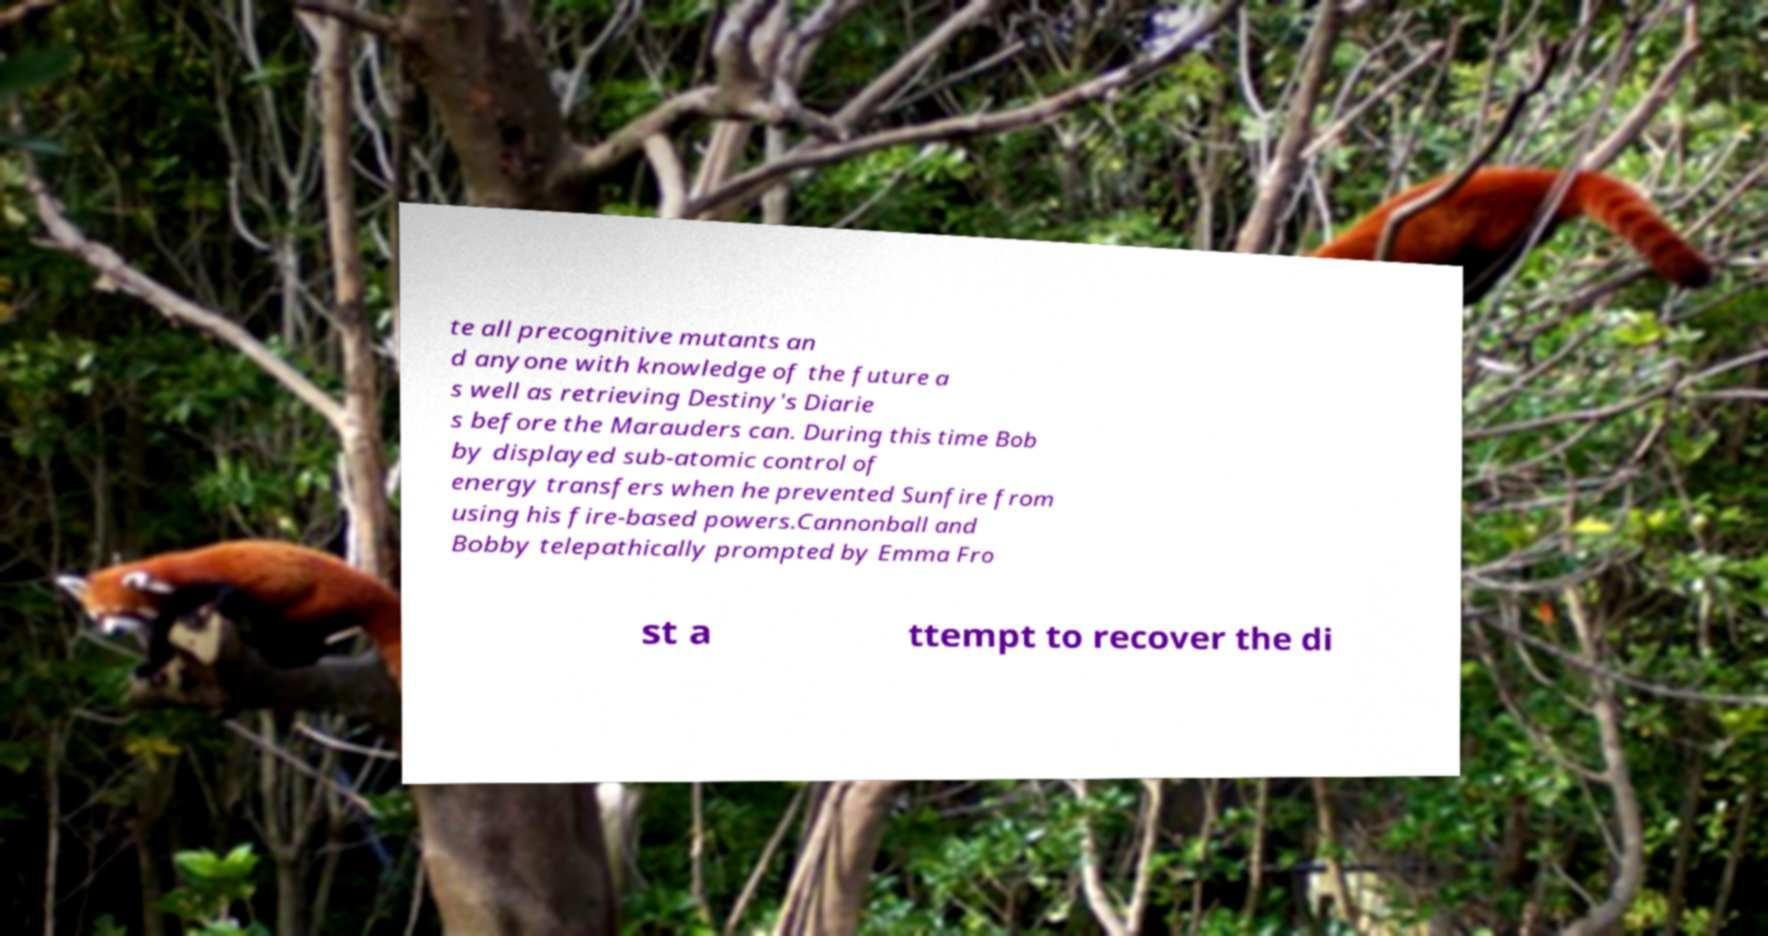Please identify and transcribe the text found in this image. te all precognitive mutants an d anyone with knowledge of the future a s well as retrieving Destiny's Diarie s before the Marauders can. During this time Bob by displayed sub-atomic control of energy transfers when he prevented Sunfire from using his fire-based powers.Cannonball and Bobby telepathically prompted by Emma Fro st a ttempt to recover the di 